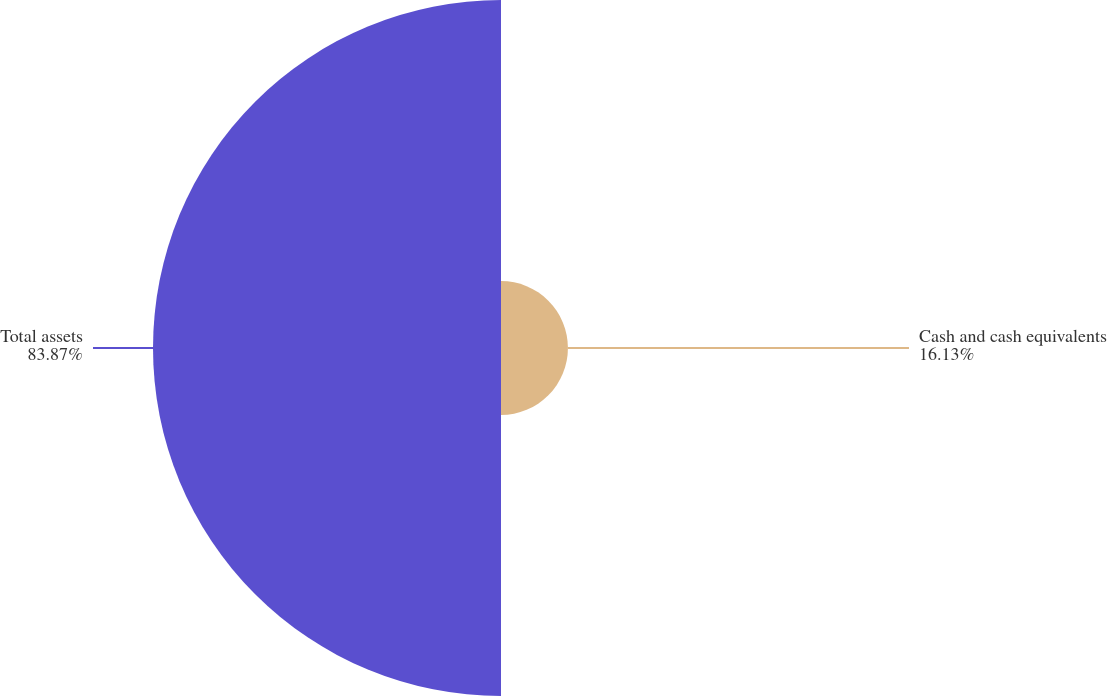Convert chart to OTSL. <chart><loc_0><loc_0><loc_500><loc_500><pie_chart><fcel>Cash and cash equivalents<fcel>Total assets<nl><fcel>16.13%<fcel>83.87%<nl></chart> 